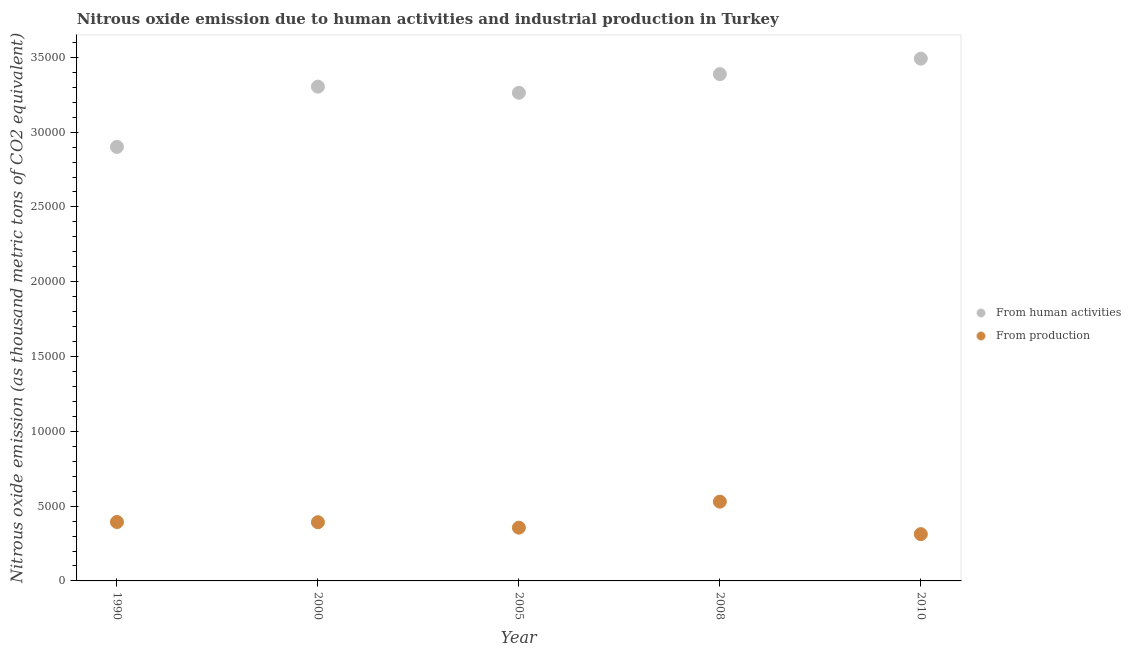Is the number of dotlines equal to the number of legend labels?
Your answer should be compact. Yes. What is the amount of emissions generated from industries in 2000?
Your answer should be very brief. 3923.9. Across all years, what is the maximum amount of emissions generated from industries?
Provide a succinct answer. 5300.3. Across all years, what is the minimum amount of emissions generated from industries?
Your answer should be very brief. 3127.4. In which year was the amount of emissions from human activities maximum?
Keep it short and to the point. 2010. In which year was the amount of emissions from human activities minimum?
Your answer should be compact. 1990. What is the total amount of emissions generated from industries in the graph?
Give a very brief answer. 1.99e+04. What is the difference between the amount of emissions generated from industries in 1990 and that in 2010?
Offer a very short reply. 810.7. What is the difference between the amount of emissions generated from industries in 2010 and the amount of emissions from human activities in 2005?
Your answer should be very brief. -2.95e+04. What is the average amount of emissions from human activities per year?
Offer a very short reply. 3.27e+04. In the year 1990, what is the difference between the amount of emissions from human activities and amount of emissions generated from industries?
Give a very brief answer. 2.51e+04. What is the ratio of the amount of emissions from human activities in 1990 to that in 2000?
Make the answer very short. 0.88. Is the amount of emissions from human activities in 1990 less than that in 2010?
Ensure brevity in your answer.  Yes. What is the difference between the highest and the second highest amount of emissions from human activities?
Your response must be concise. 1035.4. What is the difference between the highest and the lowest amount of emissions generated from industries?
Provide a succinct answer. 2172.9. Is the sum of the amount of emissions generated from industries in 2005 and 2008 greater than the maximum amount of emissions from human activities across all years?
Ensure brevity in your answer.  No. Is the amount of emissions generated from industries strictly less than the amount of emissions from human activities over the years?
Provide a short and direct response. Yes. How many dotlines are there?
Your answer should be compact. 2. Are the values on the major ticks of Y-axis written in scientific E-notation?
Offer a terse response. No. Does the graph contain any zero values?
Make the answer very short. No. Does the graph contain grids?
Give a very brief answer. No. How are the legend labels stacked?
Your answer should be compact. Vertical. What is the title of the graph?
Give a very brief answer. Nitrous oxide emission due to human activities and industrial production in Turkey. What is the label or title of the X-axis?
Make the answer very short. Year. What is the label or title of the Y-axis?
Offer a very short reply. Nitrous oxide emission (as thousand metric tons of CO2 equivalent). What is the Nitrous oxide emission (as thousand metric tons of CO2 equivalent) of From human activities in 1990?
Provide a short and direct response. 2.90e+04. What is the Nitrous oxide emission (as thousand metric tons of CO2 equivalent) in From production in 1990?
Offer a very short reply. 3938.1. What is the Nitrous oxide emission (as thousand metric tons of CO2 equivalent) of From human activities in 2000?
Offer a terse response. 3.30e+04. What is the Nitrous oxide emission (as thousand metric tons of CO2 equivalent) of From production in 2000?
Provide a succinct answer. 3923.9. What is the Nitrous oxide emission (as thousand metric tons of CO2 equivalent) in From human activities in 2005?
Your answer should be very brief. 3.26e+04. What is the Nitrous oxide emission (as thousand metric tons of CO2 equivalent) of From production in 2005?
Keep it short and to the point. 3561.4. What is the Nitrous oxide emission (as thousand metric tons of CO2 equivalent) in From human activities in 2008?
Make the answer very short. 3.39e+04. What is the Nitrous oxide emission (as thousand metric tons of CO2 equivalent) in From production in 2008?
Provide a succinct answer. 5300.3. What is the Nitrous oxide emission (as thousand metric tons of CO2 equivalent) of From human activities in 2010?
Keep it short and to the point. 3.49e+04. What is the Nitrous oxide emission (as thousand metric tons of CO2 equivalent) in From production in 2010?
Provide a succinct answer. 3127.4. Across all years, what is the maximum Nitrous oxide emission (as thousand metric tons of CO2 equivalent) of From human activities?
Your answer should be very brief. 3.49e+04. Across all years, what is the maximum Nitrous oxide emission (as thousand metric tons of CO2 equivalent) in From production?
Offer a very short reply. 5300.3. Across all years, what is the minimum Nitrous oxide emission (as thousand metric tons of CO2 equivalent) of From human activities?
Provide a succinct answer. 2.90e+04. Across all years, what is the minimum Nitrous oxide emission (as thousand metric tons of CO2 equivalent) of From production?
Give a very brief answer. 3127.4. What is the total Nitrous oxide emission (as thousand metric tons of CO2 equivalent) of From human activities in the graph?
Offer a very short reply. 1.63e+05. What is the total Nitrous oxide emission (as thousand metric tons of CO2 equivalent) of From production in the graph?
Your answer should be compact. 1.99e+04. What is the difference between the Nitrous oxide emission (as thousand metric tons of CO2 equivalent) in From human activities in 1990 and that in 2000?
Your answer should be compact. -4027.6. What is the difference between the Nitrous oxide emission (as thousand metric tons of CO2 equivalent) of From human activities in 1990 and that in 2005?
Your answer should be compact. -3617.4. What is the difference between the Nitrous oxide emission (as thousand metric tons of CO2 equivalent) in From production in 1990 and that in 2005?
Make the answer very short. 376.7. What is the difference between the Nitrous oxide emission (as thousand metric tons of CO2 equivalent) in From human activities in 1990 and that in 2008?
Offer a very short reply. -4864.2. What is the difference between the Nitrous oxide emission (as thousand metric tons of CO2 equivalent) of From production in 1990 and that in 2008?
Make the answer very short. -1362.2. What is the difference between the Nitrous oxide emission (as thousand metric tons of CO2 equivalent) in From human activities in 1990 and that in 2010?
Give a very brief answer. -5899.6. What is the difference between the Nitrous oxide emission (as thousand metric tons of CO2 equivalent) of From production in 1990 and that in 2010?
Ensure brevity in your answer.  810.7. What is the difference between the Nitrous oxide emission (as thousand metric tons of CO2 equivalent) of From human activities in 2000 and that in 2005?
Ensure brevity in your answer.  410.2. What is the difference between the Nitrous oxide emission (as thousand metric tons of CO2 equivalent) in From production in 2000 and that in 2005?
Offer a terse response. 362.5. What is the difference between the Nitrous oxide emission (as thousand metric tons of CO2 equivalent) in From human activities in 2000 and that in 2008?
Your answer should be very brief. -836.6. What is the difference between the Nitrous oxide emission (as thousand metric tons of CO2 equivalent) in From production in 2000 and that in 2008?
Your response must be concise. -1376.4. What is the difference between the Nitrous oxide emission (as thousand metric tons of CO2 equivalent) of From human activities in 2000 and that in 2010?
Ensure brevity in your answer.  -1872. What is the difference between the Nitrous oxide emission (as thousand metric tons of CO2 equivalent) of From production in 2000 and that in 2010?
Provide a short and direct response. 796.5. What is the difference between the Nitrous oxide emission (as thousand metric tons of CO2 equivalent) of From human activities in 2005 and that in 2008?
Provide a succinct answer. -1246.8. What is the difference between the Nitrous oxide emission (as thousand metric tons of CO2 equivalent) in From production in 2005 and that in 2008?
Your answer should be very brief. -1738.9. What is the difference between the Nitrous oxide emission (as thousand metric tons of CO2 equivalent) of From human activities in 2005 and that in 2010?
Your answer should be very brief. -2282.2. What is the difference between the Nitrous oxide emission (as thousand metric tons of CO2 equivalent) of From production in 2005 and that in 2010?
Keep it short and to the point. 434. What is the difference between the Nitrous oxide emission (as thousand metric tons of CO2 equivalent) in From human activities in 2008 and that in 2010?
Make the answer very short. -1035.4. What is the difference between the Nitrous oxide emission (as thousand metric tons of CO2 equivalent) of From production in 2008 and that in 2010?
Offer a terse response. 2172.9. What is the difference between the Nitrous oxide emission (as thousand metric tons of CO2 equivalent) in From human activities in 1990 and the Nitrous oxide emission (as thousand metric tons of CO2 equivalent) in From production in 2000?
Ensure brevity in your answer.  2.51e+04. What is the difference between the Nitrous oxide emission (as thousand metric tons of CO2 equivalent) of From human activities in 1990 and the Nitrous oxide emission (as thousand metric tons of CO2 equivalent) of From production in 2005?
Offer a very short reply. 2.55e+04. What is the difference between the Nitrous oxide emission (as thousand metric tons of CO2 equivalent) in From human activities in 1990 and the Nitrous oxide emission (as thousand metric tons of CO2 equivalent) in From production in 2008?
Keep it short and to the point. 2.37e+04. What is the difference between the Nitrous oxide emission (as thousand metric tons of CO2 equivalent) of From human activities in 1990 and the Nitrous oxide emission (as thousand metric tons of CO2 equivalent) of From production in 2010?
Offer a terse response. 2.59e+04. What is the difference between the Nitrous oxide emission (as thousand metric tons of CO2 equivalent) of From human activities in 2000 and the Nitrous oxide emission (as thousand metric tons of CO2 equivalent) of From production in 2005?
Make the answer very short. 2.95e+04. What is the difference between the Nitrous oxide emission (as thousand metric tons of CO2 equivalent) of From human activities in 2000 and the Nitrous oxide emission (as thousand metric tons of CO2 equivalent) of From production in 2008?
Your answer should be compact. 2.77e+04. What is the difference between the Nitrous oxide emission (as thousand metric tons of CO2 equivalent) in From human activities in 2000 and the Nitrous oxide emission (as thousand metric tons of CO2 equivalent) in From production in 2010?
Your answer should be very brief. 2.99e+04. What is the difference between the Nitrous oxide emission (as thousand metric tons of CO2 equivalent) of From human activities in 2005 and the Nitrous oxide emission (as thousand metric tons of CO2 equivalent) of From production in 2008?
Keep it short and to the point. 2.73e+04. What is the difference between the Nitrous oxide emission (as thousand metric tons of CO2 equivalent) in From human activities in 2005 and the Nitrous oxide emission (as thousand metric tons of CO2 equivalent) in From production in 2010?
Give a very brief answer. 2.95e+04. What is the difference between the Nitrous oxide emission (as thousand metric tons of CO2 equivalent) of From human activities in 2008 and the Nitrous oxide emission (as thousand metric tons of CO2 equivalent) of From production in 2010?
Your answer should be compact. 3.08e+04. What is the average Nitrous oxide emission (as thousand metric tons of CO2 equivalent) in From human activities per year?
Keep it short and to the point. 3.27e+04. What is the average Nitrous oxide emission (as thousand metric tons of CO2 equivalent) in From production per year?
Your answer should be compact. 3970.22. In the year 1990, what is the difference between the Nitrous oxide emission (as thousand metric tons of CO2 equivalent) of From human activities and Nitrous oxide emission (as thousand metric tons of CO2 equivalent) of From production?
Keep it short and to the point. 2.51e+04. In the year 2000, what is the difference between the Nitrous oxide emission (as thousand metric tons of CO2 equivalent) in From human activities and Nitrous oxide emission (as thousand metric tons of CO2 equivalent) in From production?
Your answer should be compact. 2.91e+04. In the year 2005, what is the difference between the Nitrous oxide emission (as thousand metric tons of CO2 equivalent) in From human activities and Nitrous oxide emission (as thousand metric tons of CO2 equivalent) in From production?
Ensure brevity in your answer.  2.91e+04. In the year 2008, what is the difference between the Nitrous oxide emission (as thousand metric tons of CO2 equivalent) in From human activities and Nitrous oxide emission (as thousand metric tons of CO2 equivalent) in From production?
Ensure brevity in your answer.  2.86e+04. In the year 2010, what is the difference between the Nitrous oxide emission (as thousand metric tons of CO2 equivalent) of From human activities and Nitrous oxide emission (as thousand metric tons of CO2 equivalent) of From production?
Provide a succinct answer. 3.18e+04. What is the ratio of the Nitrous oxide emission (as thousand metric tons of CO2 equivalent) of From human activities in 1990 to that in 2000?
Ensure brevity in your answer.  0.88. What is the ratio of the Nitrous oxide emission (as thousand metric tons of CO2 equivalent) in From production in 1990 to that in 2000?
Keep it short and to the point. 1. What is the ratio of the Nitrous oxide emission (as thousand metric tons of CO2 equivalent) of From human activities in 1990 to that in 2005?
Provide a short and direct response. 0.89. What is the ratio of the Nitrous oxide emission (as thousand metric tons of CO2 equivalent) in From production in 1990 to that in 2005?
Give a very brief answer. 1.11. What is the ratio of the Nitrous oxide emission (as thousand metric tons of CO2 equivalent) of From human activities in 1990 to that in 2008?
Your answer should be very brief. 0.86. What is the ratio of the Nitrous oxide emission (as thousand metric tons of CO2 equivalent) in From production in 1990 to that in 2008?
Offer a terse response. 0.74. What is the ratio of the Nitrous oxide emission (as thousand metric tons of CO2 equivalent) of From human activities in 1990 to that in 2010?
Provide a short and direct response. 0.83. What is the ratio of the Nitrous oxide emission (as thousand metric tons of CO2 equivalent) of From production in 1990 to that in 2010?
Make the answer very short. 1.26. What is the ratio of the Nitrous oxide emission (as thousand metric tons of CO2 equivalent) of From human activities in 2000 to that in 2005?
Your answer should be compact. 1.01. What is the ratio of the Nitrous oxide emission (as thousand metric tons of CO2 equivalent) of From production in 2000 to that in 2005?
Make the answer very short. 1.1. What is the ratio of the Nitrous oxide emission (as thousand metric tons of CO2 equivalent) in From human activities in 2000 to that in 2008?
Offer a terse response. 0.98. What is the ratio of the Nitrous oxide emission (as thousand metric tons of CO2 equivalent) in From production in 2000 to that in 2008?
Your response must be concise. 0.74. What is the ratio of the Nitrous oxide emission (as thousand metric tons of CO2 equivalent) in From human activities in 2000 to that in 2010?
Give a very brief answer. 0.95. What is the ratio of the Nitrous oxide emission (as thousand metric tons of CO2 equivalent) in From production in 2000 to that in 2010?
Keep it short and to the point. 1.25. What is the ratio of the Nitrous oxide emission (as thousand metric tons of CO2 equivalent) in From human activities in 2005 to that in 2008?
Provide a succinct answer. 0.96. What is the ratio of the Nitrous oxide emission (as thousand metric tons of CO2 equivalent) in From production in 2005 to that in 2008?
Keep it short and to the point. 0.67. What is the ratio of the Nitrous oxide emission (as thousand metric tons of CO2 equivalent) in From human activities in 2005 to that in 2010?
Your answer should be compact. 0.93. What is the ratio of the Nitrous oxide emission (as thousand metric tons of CO2 equivalent) of From production in 2005 to that in 2010?
Offer a terse response. 1.14. What is the ratio of the Nitrous oxide emission (as thousand metric tons of CO2 equivalent) of From human activities in 2008 to that in 2010?
Give a very brief answer. 0.97. What is the ratio of the Nitrous oxide emission (as thousand metric tons of CO2 equivalent) in From production in 2008 to that in 2010?
Offer a very short reply. 1.69. What is the difference between the highest and the second highest Nitrous oxide emission (as thousand metric tons of CO2 equivalent) of From human activities?
Make the answer very short. 1035.4. What is the difference between the highest and the second highest Nitrous oxide emission (as thousand metric tons of CO2 equivalent) in From production?
Provide a succinct answer. 1362.2. What is the difference between the highest and the lowest Nitrous oxide emission (as thousand metric tons of CO2 equivalent) in From human activities?
Your answer should be compact. 5899.6. What is the difference between the highest and the lowest Nitrous oxide emission (as thousand metric tons of CO2 equivalent) in From production?
Offer a terse response. 2172.9. 